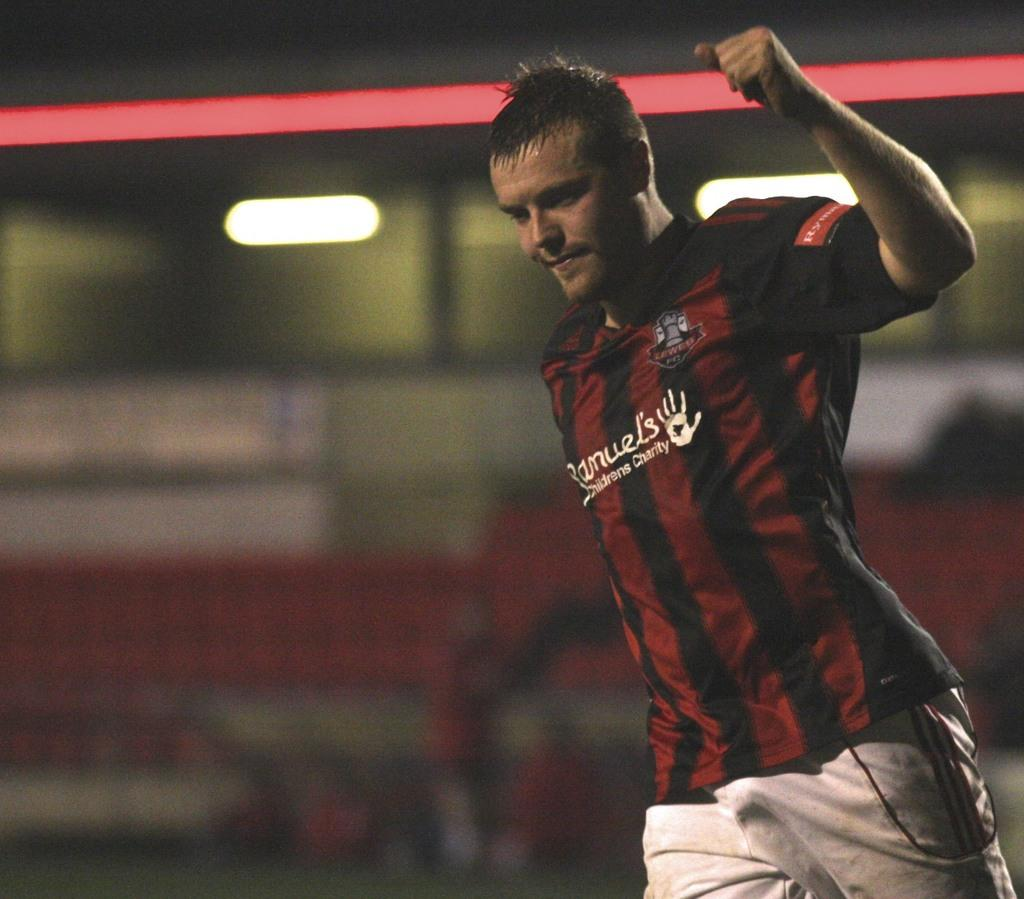What can be seen in the image? There is a person in the image. What is the person wearing? The person is wearing a black and white shirt and white color pants. How would you describe the background of the image? The background of the image is blurred. Can you see a crown on the person's head in the image? No, there is no crown visible on the person's head in the image. 